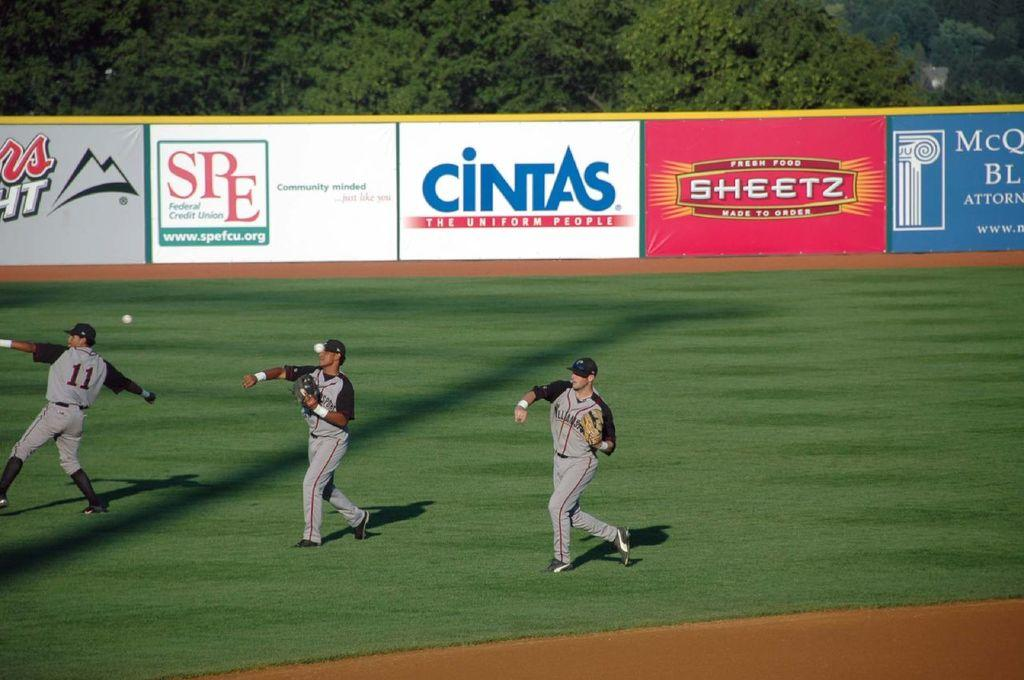<image>
Create a compact narrative representing the image presented. a cintas sign that is in the outfield 